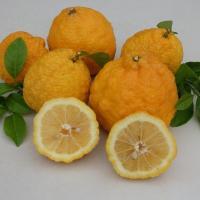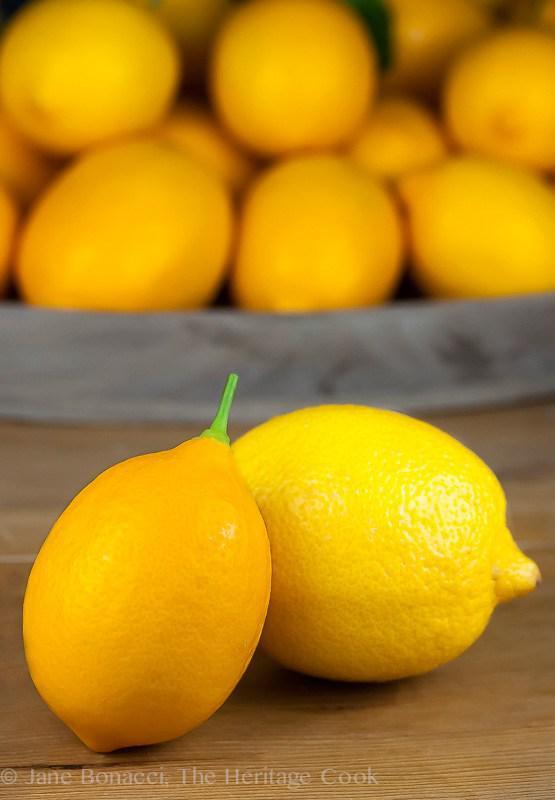The first image is the image on the left, the second image is the image on the right. For the images displayed, is the sentence "The left image shows sliced fruit and the right image shows whole fruit." factually correct? Answer yes or no. Yes. The first image is the image on the left, the second image is the image on the right. Evaluate the accuracy of this statement regarding the images: "There are only two whole lemons in one of the images.". Is it true? Answer yes or no. No. 